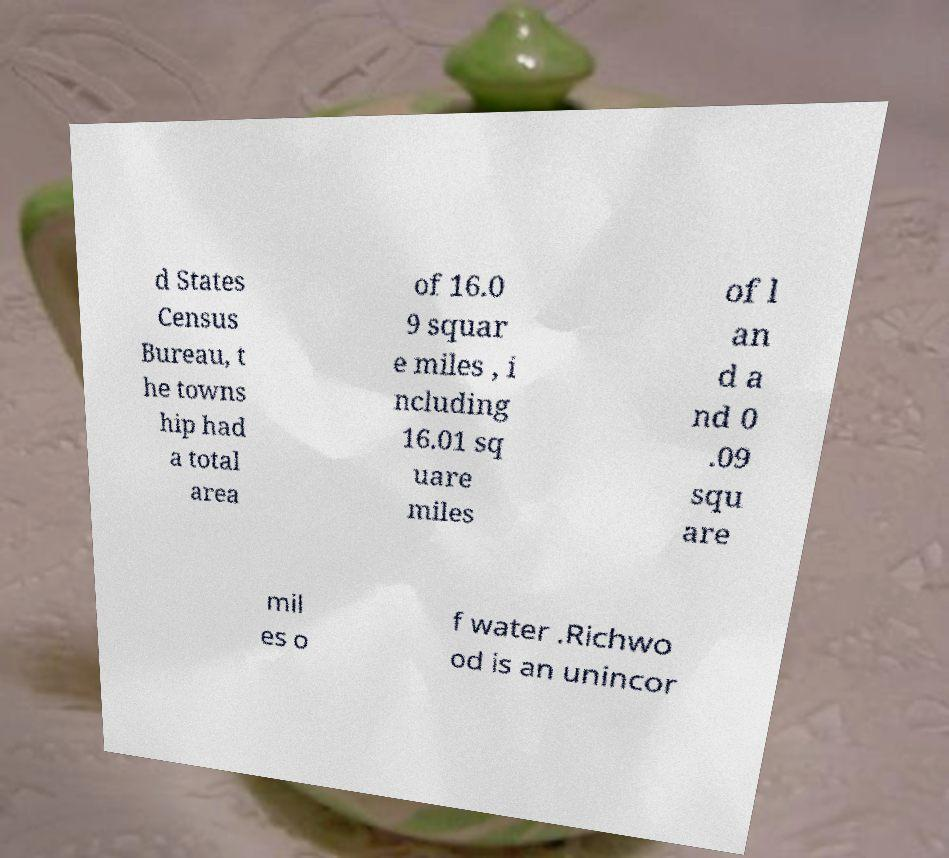Could you extract and type out the text from this image? d States Census Bureau, t he towns hip had a total area of 16.0 9 squar e miles , i ncluding 16.01 sq uare miles of l an d a nd 0 .09 squ are mil es o f water .Richwo od is an unincor 